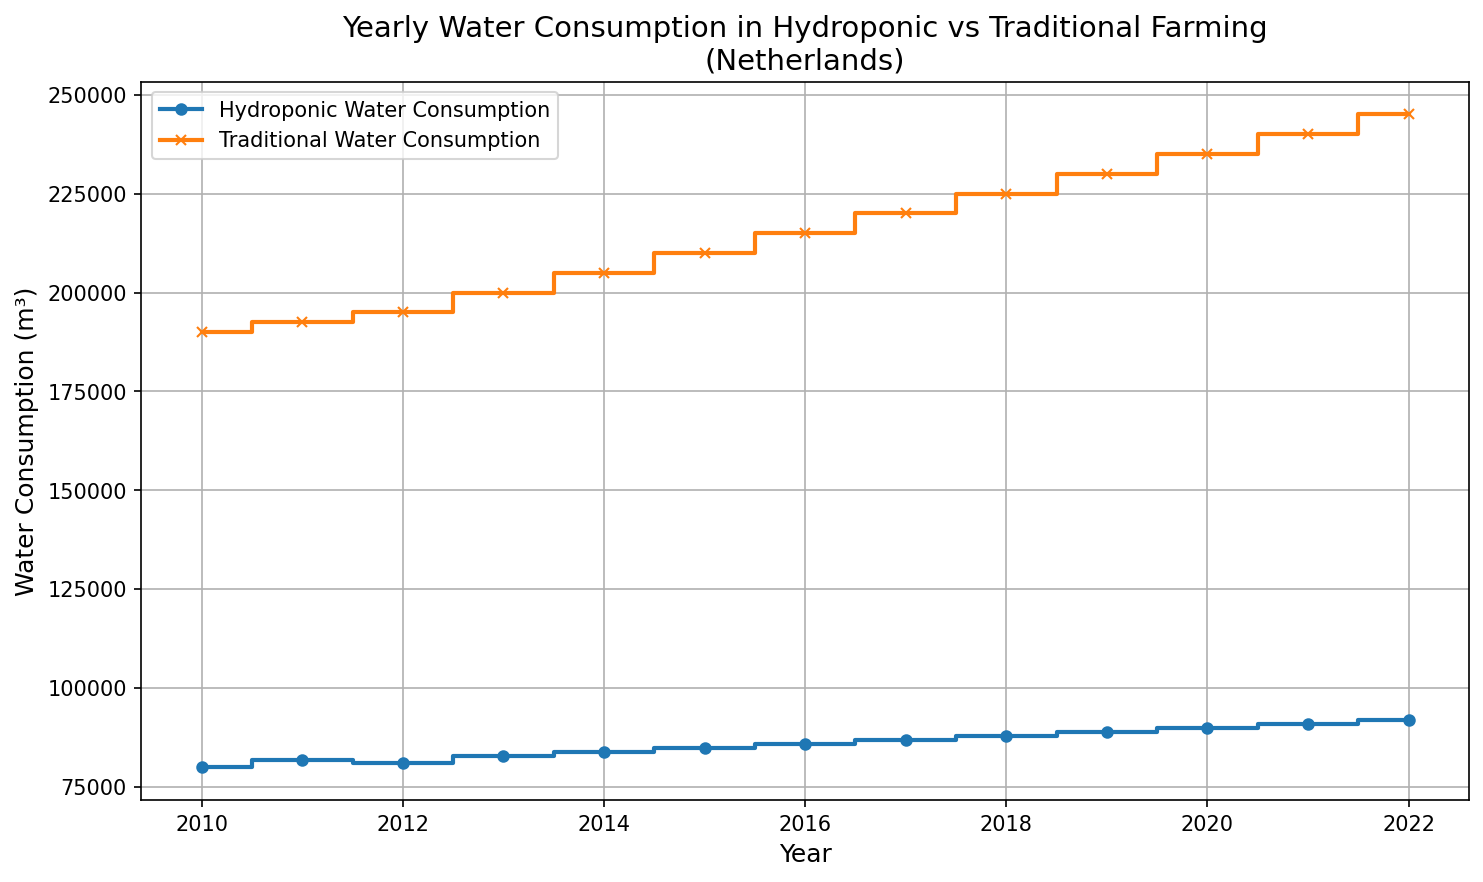Which year has the lowest water consumption for hydroponic farming? To determine the year with the lowest hydroponic water consumption, examine the hydroponic water consumption data points. The figure indicates the lowest value is in 2010.
Answer: 2010 What is the difference in water consumption between hydroponic and traditional farming in 2022? The figure shows the water consumption for 2022: hydroponic (92,000 m³) and traditional (245,000 m³). Calculating the difference: 245,000 - 92,000.
Answer: 153,000 m³ How does the water consumption trend for hydroponic farming compare to traditional farming over the years? Both methods show an increasing trend over the years, but the traditional method has consistently higher water consumption compared to hydroponic farming.
Answer: Both increase, but traditional is higher Which year shows the largest difference in water consumption between the two farming methods? To find the year with the largest difference, compare the differences for each year. The differences increase over time, with the largest difference in 2022 (245,000 - 92,000).
Answer: 2022 What is the average annual water consumption for traditional farming from 2010 to 2022? Sum the traditional consumption values (1,030,000) then divide by the number of years (13). 1,030,000/13.
Answer: 198,076.92 m³ In 2015, how much more water does traditional farming consume compared to hydroponic farming? For 2015, compare traditional (210,000 m³) to hydroponic (85,000 m³). The difference is 210,000 - 85,000.
Answer: 125,000 m³ What is the percentage increase in hydroponic water consumption from 2010 to 2022? Calculate the percentage increase: (92,000 - 80,000) / 80,000 * 100%. This results in 12,000 / 80,000 * 100.
Answer: 15% Which farming method has a steeper increase in water consumption over the examined period? By visual comparison of the slopes, traditional farming shows a steeper increase compared to hydroponic farming from 2010 to 2022.
Answer: Traditional farming What are the years where the water consumption for hydroponic farming remains the same as the previous year? Check the plot for years where the hydroponic line remains level. No such years are indicated; water consumption increases every year.
Answer: None Looking at the plot, which color line represents the hydroponic water consumption? The hydroponic water consumption is represented by the blue line in the plot.
Answer: Blue 